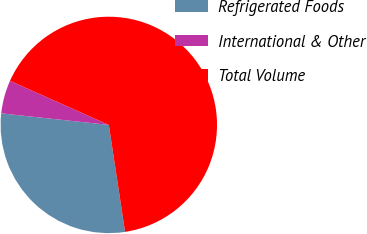<chart> <loc_0><loc_0><loc_500><loc_500><pie_chart><fcel>Refrigerated Foods<fcel>International & Other<fcel>Total Volume<nl><fcel>29.11%<fcel>4.98%<fcel>65.91%<nl></chart> 